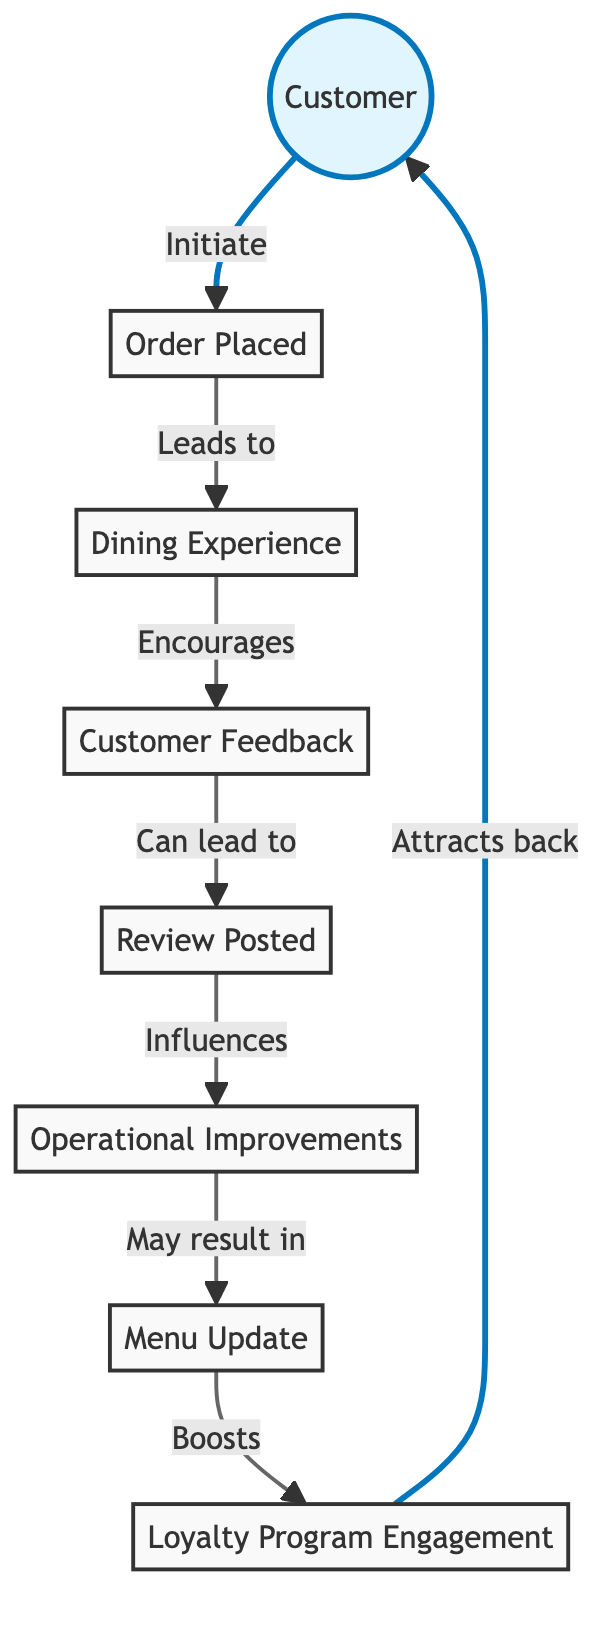What is the total number of nodes in the diagram? There are eight nodes in the diagram: Customer, Order, Experience, Feedback, Review, Improvements, Menu Update, and Loyalty. Counting each of these nodes gives a total of eight.
Answer: 8 What is the relationship between Customer and Order? The relationship is indicated by the edge labeled "Initiate," which shows that the Customer initiates the Order.
Answer: Initiate Which node comes after Dining Experience in the flow? The node that follows Dining Experience is Feedback, as indicated by the edge labeled "Encourages."
Answer: Feedback How does the Review node affect the overall process? The Review node influences the Improvements node, meaning that feedback posted can lead to operational enhancements.
Answer: Influences What happens after Operational Improvements are made? After Operational Improvements, there may result in a Menu Update, showing a direct link from Improvements to Menu Update through the edge labeled "May result in."
Answer: Menu Update How many edges connect the Customer to the Loyalty program and what are they? There are two edges connecting Customer to Loyalty: one via the Order (initiating the process) and the other through the sequence of interactions ending in Loyalty, which attracts the customer back.
Answer: 2 edges What does the edge from Menu Update to Loyalty signify? The edge labeled "Boosts" signifies that a Menu Update can enhance or increase engagement with the Loyalty Program.
Answer: Boosts In which direction does the flow primarily move in the diagram? The flow primarily moves from left to right, starting with the Customer and ending with the Loyalty Program, indicating a cyclical feedback process.
Answer: Left to right 